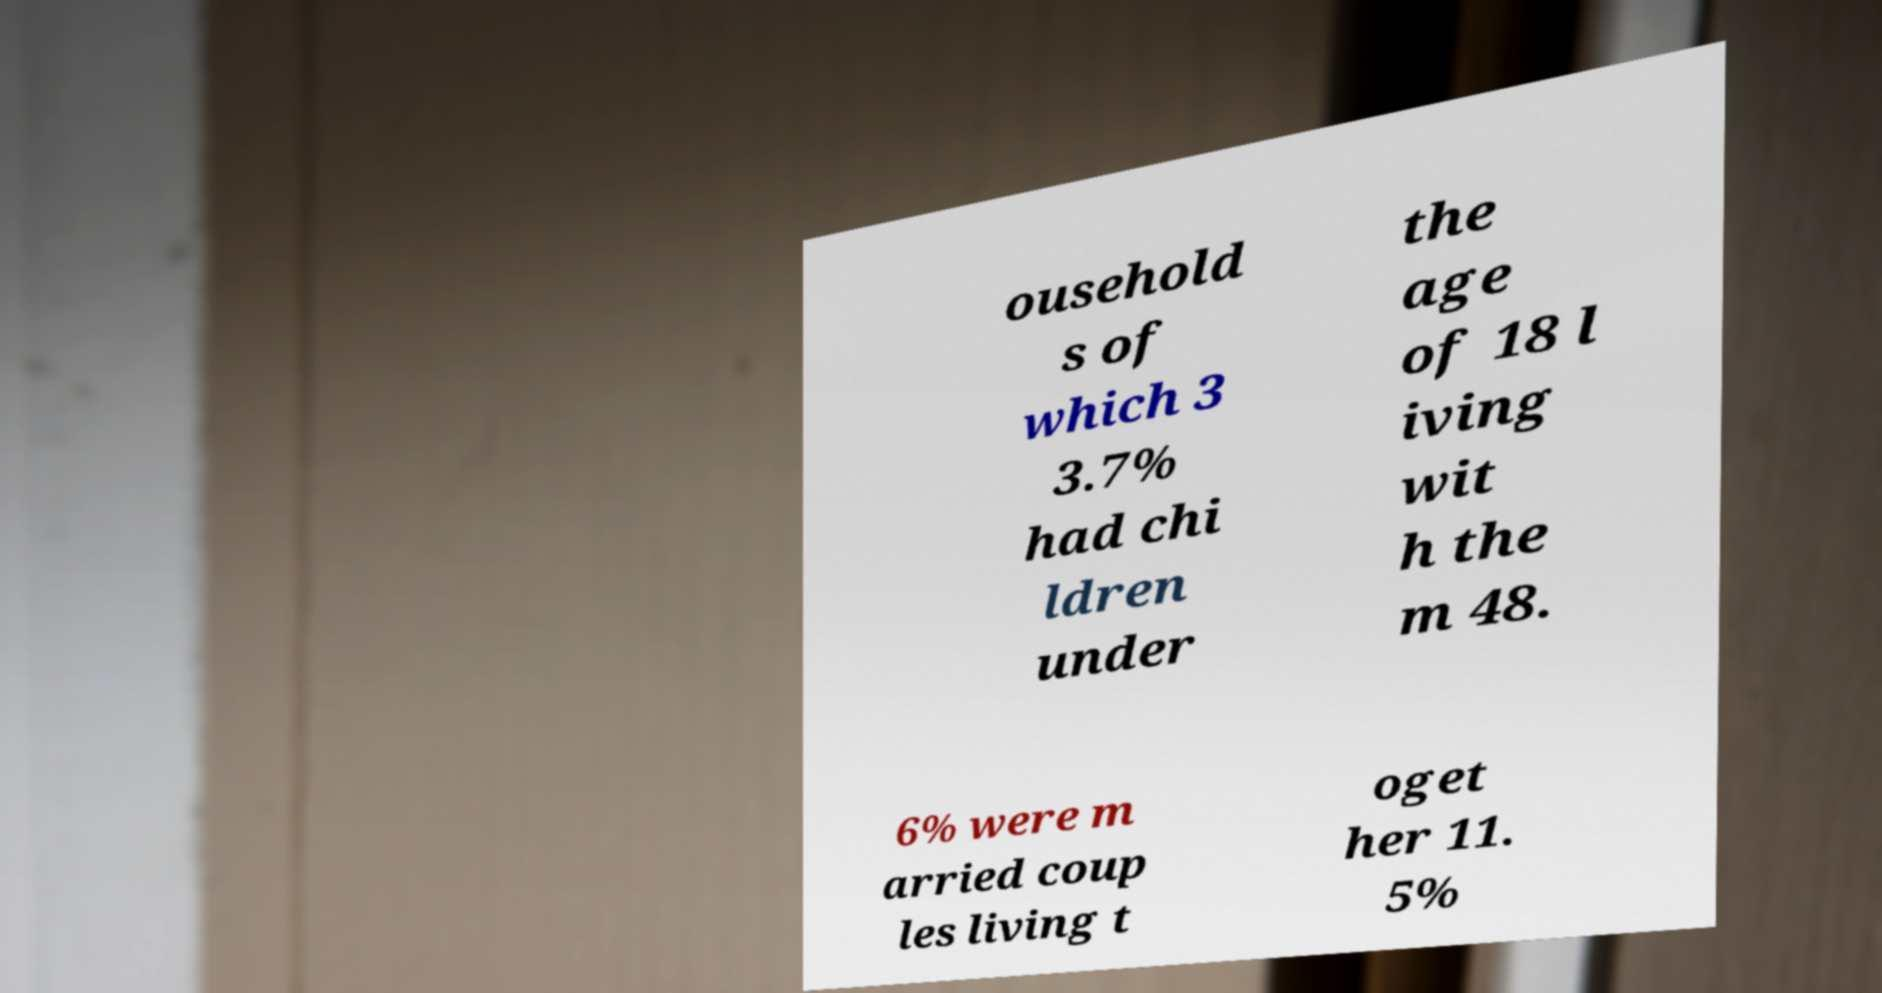Could you assist in decoding the text presented in this image and type it out clearly? ousehold s of which 3 3.7% had chi ldren under the age of 18 l iving wit h the m 48. 6% were m arried coup les living t oget her 11. 5% 